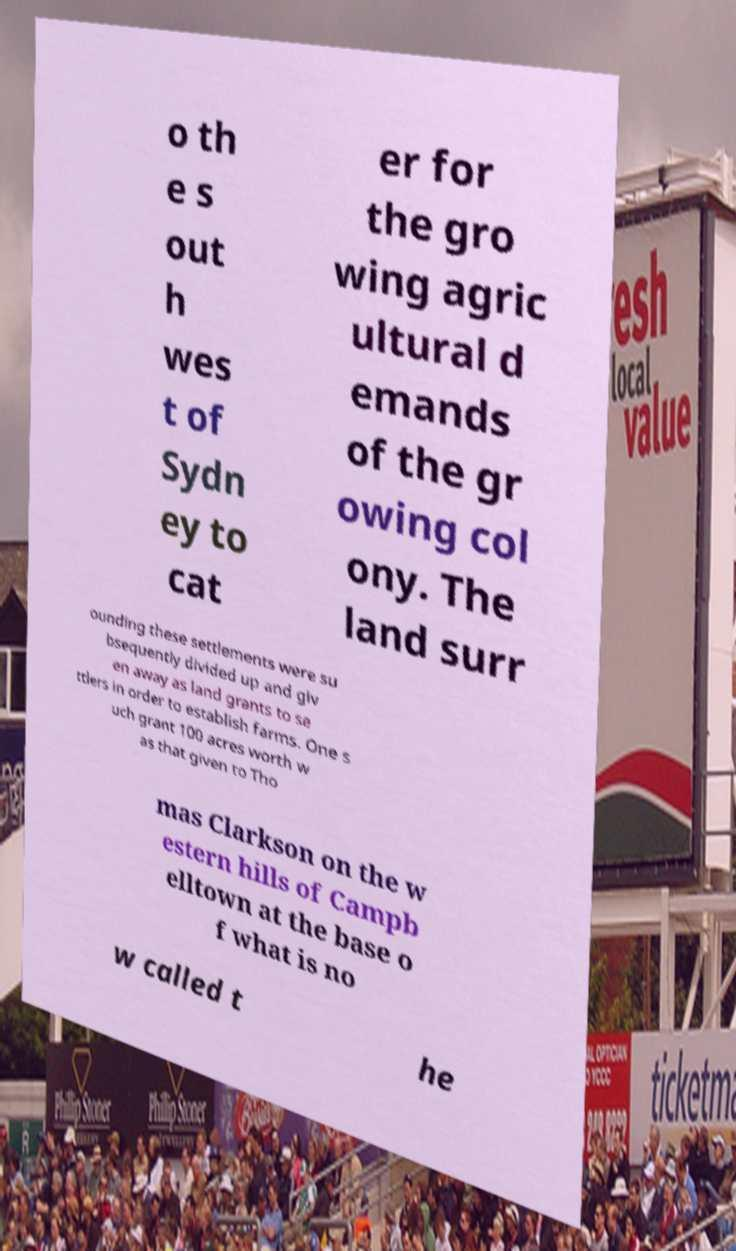Can you read and provide the text displayed in the image?This photo seems to have some interesting text. Can you extract and type it out for me? o th e s out h wes t of Sydn ey to cat er for the gro wing agric ultural d emands of the gr owing col ony. The land surr ounding these settlements were su bsequently divided up and giv en away as land grants to se ttlers in order to establish farms. One s uch grant 100 acres worth w as that given to Tho mas Clarkson on the w estern hills of Campb elltown at the base o f what is no w called t he 